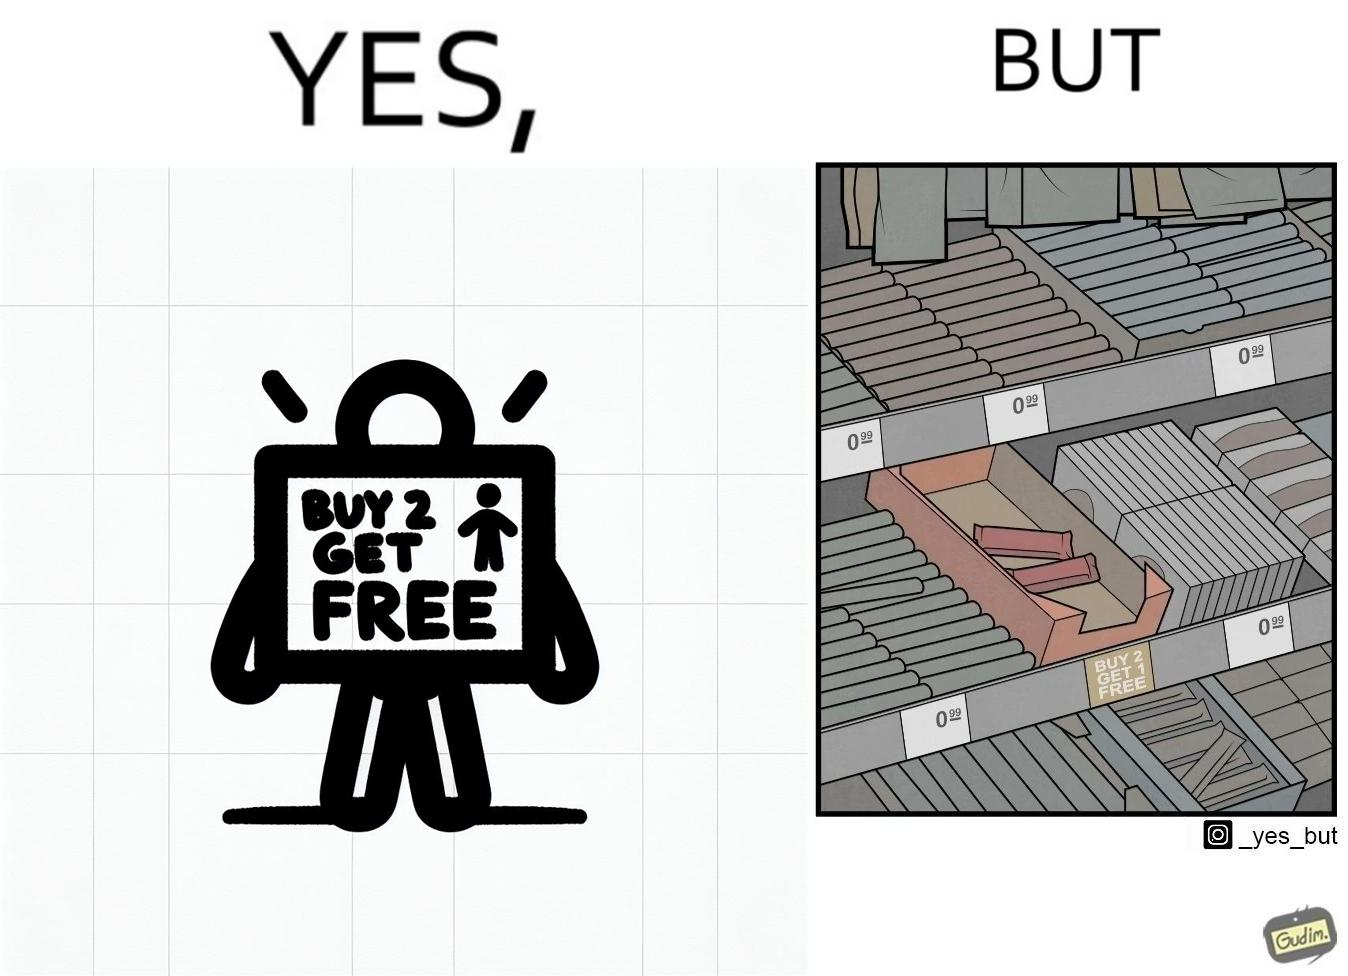Would you classify this image as satirical? Yes, this image is satirical. 